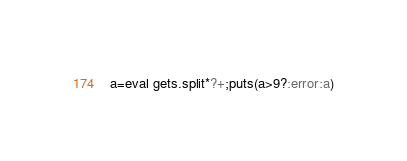Convert code to text. <code><loc_0><loc_0><loc_500><loc_500><_Ruby_>a=eval gets.split*?+;puts(a>9?:error:a)</code> 